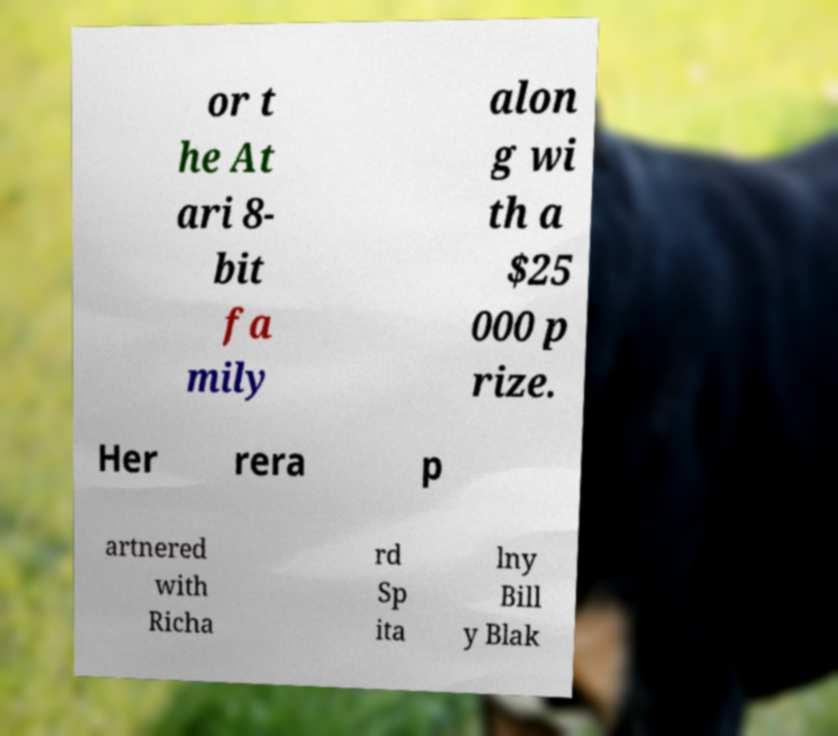What messages or text are displayed in this image? I need them in a readable, typed format. or t he At ari 8- bit fa mily alon g wi th a $25 000 p rize. Her rera p artnered with Richa rd Sp ita lny Bill y Blak 